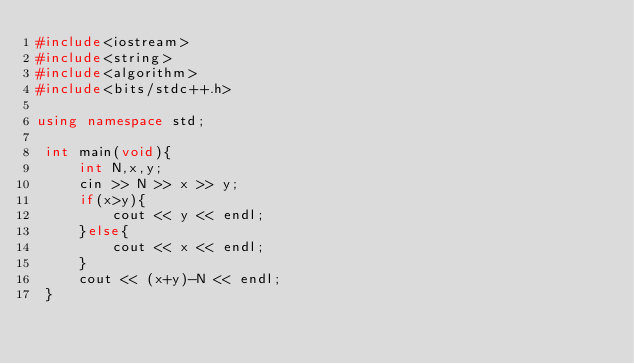Convert code to text. <code><loc_0><loc_0><loc_500><loc_500><_C++_>#include<iostream>
#include<string>
#include<algorithm>
#include<bits/stdc++.h>
 
using namespace std;
 
 int main(void){
     int N,x,y;
     cin >> N >> x >> y;
     if(x>y){
         cout << y << endl;
     }else{
         cout << x << endl;
     }
     cout << (x+y)-N << endl;
 }</code> 